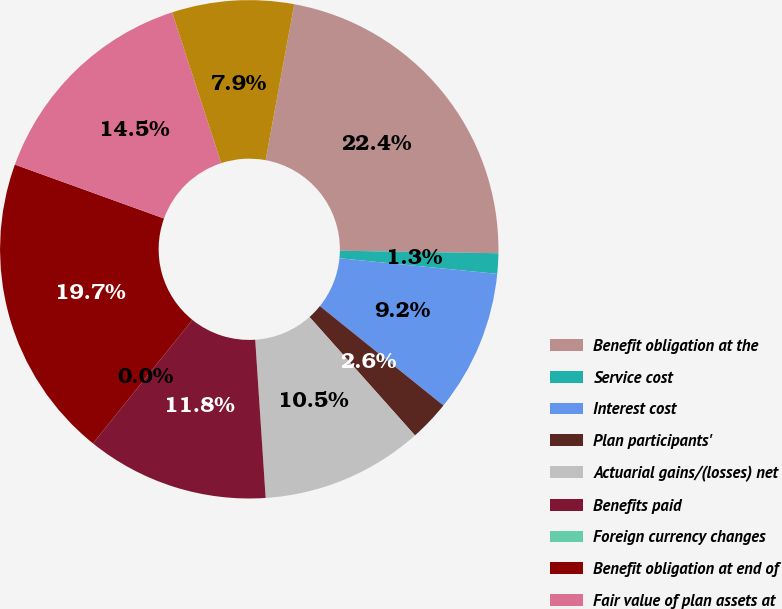<chart> <loc_0><loc_0><loc_500><loc_500><pie_chart><fcel>Benefit obligation at the<fcel>Service cost<fcel>Interest cost<fcel>Plan participants'<fcel>Actuarial gains/(losses) net<fcel>Benefits paid<fcel>Foreign currency changes<fcel>Benefit obligation at end of<fcel>Fair value of plan assets at<fcel>Actual return on plan assets<nl><fcel>22.36%<fcel>1.32%<fcel>9.21%<fcel>2.64%<fcel>10.53%<fcel>11.84%<fcel>0.0%<fcel>19.73%<fcel>14.47%<fcel>7.9%<nl></chart> 